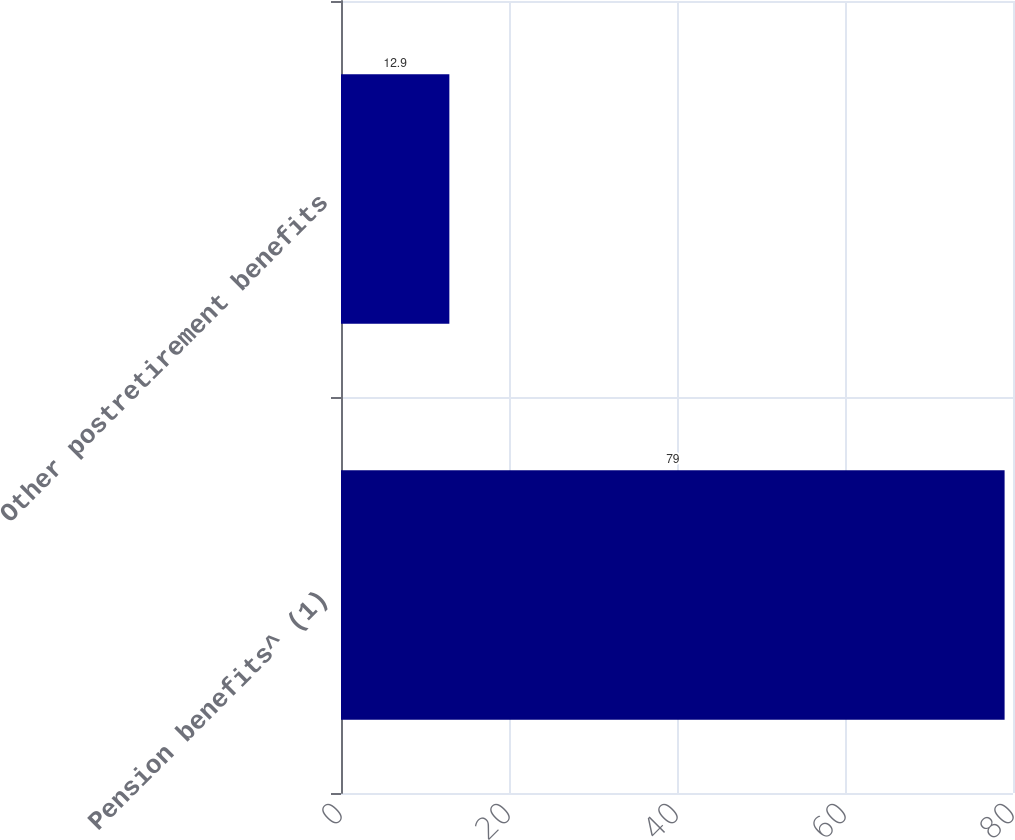Convert chart to OTSL. <chart><loc_0><loc_0><loc_500><loc_500><bar_chart><fcel>Pension benefits^ (1)<fcel>Other postretirement benefits<nl><fcel>79<fcel>12.9<nl></chart> 